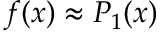Convert formula to latex. <formula><loc_0><loc_0><loc_500><loc_500>f ( x ) \approx P _ { 1 } ( x )</formula> 